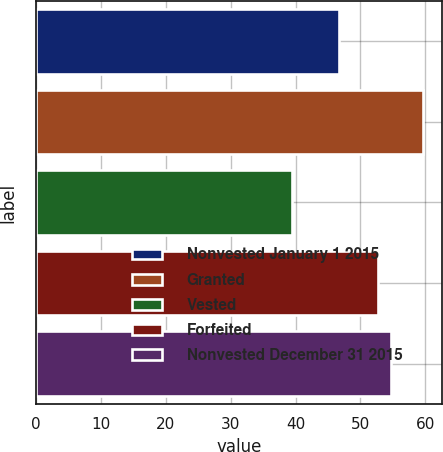Convert chart. <chart><loc_0><loc_0><loc_500><loc_500><bar_chart><fcel>Nonvested January 1 2015<fcel>Granted<fcel>Vested<fcel>Forfeited<fcel>Nonvested December 31 2015<nl><fcel>46.66<fcel>59.66<fcel>39.45<fcel>52.64<fcel>54.66<nl></chart> 